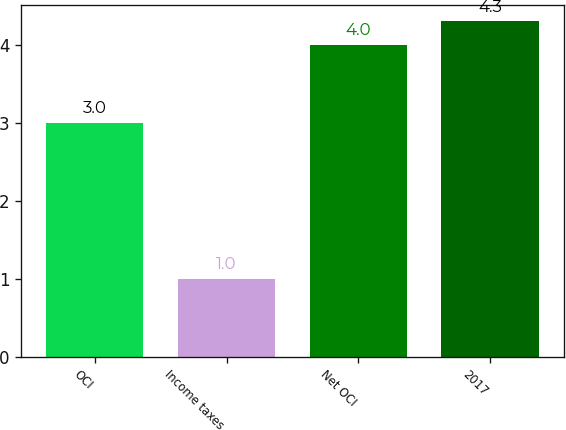<chart> <loc_0><loc_0><loc_500><loc_500><bar_chart><fcel>OCI<fcel>Income taxes<fcel>Net OCI<fcel>2017<nl><fcel>3<fcel>1<fcel>4<fcel>4.3<nl></chart> 